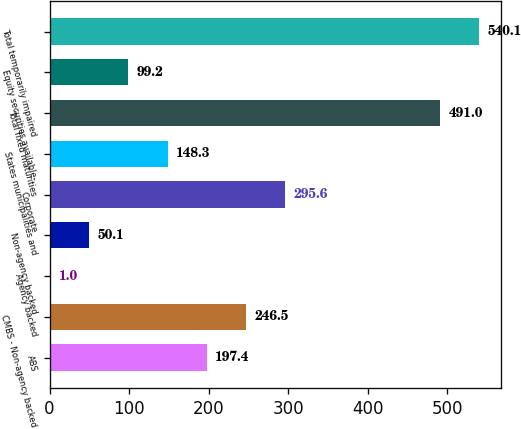Convert chart to OTSL. <chart><loc_0><loc_0><loc_500><loc_500><bar_chart><fcel>ABS<fcel>CMBS - Non-agency backed<fcel>Agency backed<fcel>Non-agency backed<fcel>Corporate<fcel>States municipalities and<fcel>Total fixed maturities<fcel>Equity securities available-<fcel>Total temporarily impaired<nl><fcel>197.4<fcel>246.5<fcel>1<fcel>50.1<fcel>295.6<fcel>148.3<fcel>491<fcel>99.2<fcel>540.1<nl></chart> 